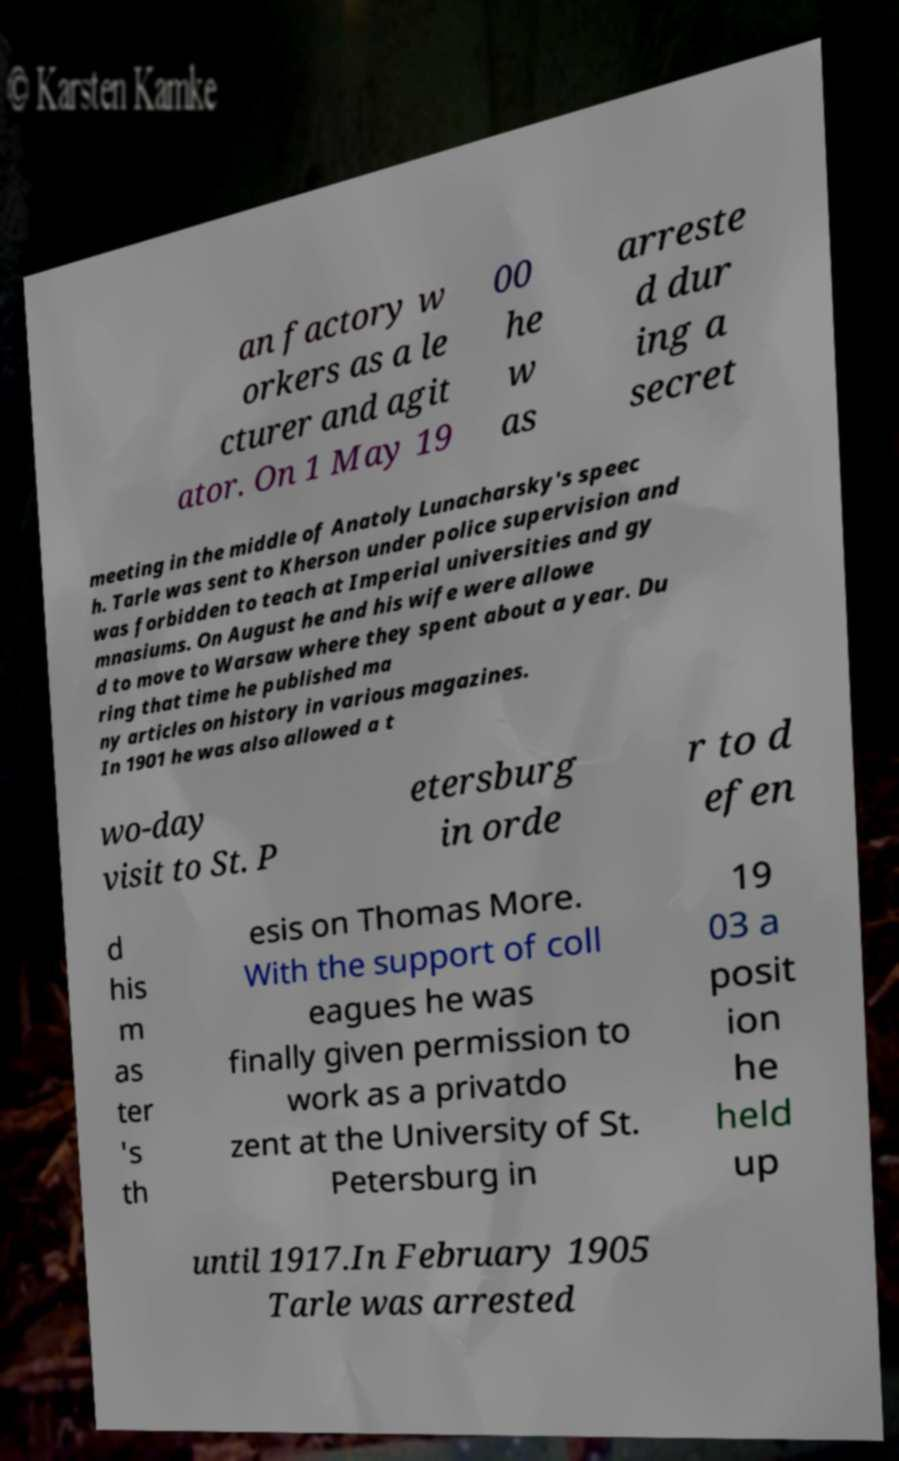What messages or text are displayed in this image? I need them in a readable, typed format. an factory w orkers as a le cturer and agit ator. On 1 May 19 00 he w as arreste d dur ing a secret meeting in the middle of Anatoly Lunacharsky's speec h. Tarle was sent to Kherson under police supervision and was forbidden to teach at Imperial universities and gy mnasiums. On August he and his wife were allowe d to move to Warsaw where they spent about a year. Du ring that time he published ma ny articles on history in various magazines. In 1901 he was also allowed a t wo-day visit to St. P etersburg in orde r to d efen d his m as ter 's th esis on Thomas More. With the support of coll eagues he was finally given permission to work as a privatdo zent at the University of St. Petersburg in 19 03 a posit ion he held up until 1917.In February 1905 Tarle was arrested 